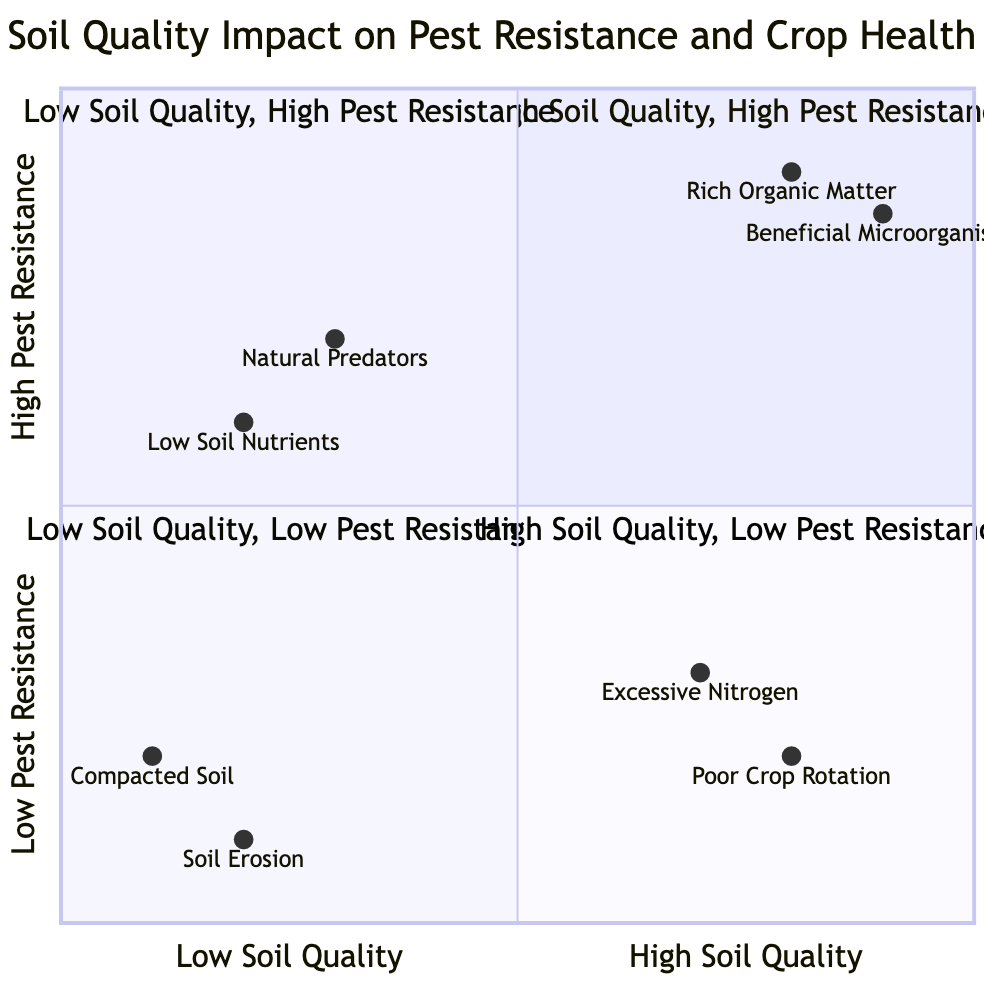What elements are found in the "High Soil Quality, High Pest Resistance" quadrant? The "High Soil Quality, High Pest Resistance" quadrant contains two elements: "Rich Organic Matter" and "Beneficial Microorganisms."
Answer: Rich Organic Matter, Beneficial Microorganisms What does "Compacted Soil" indicate about pest resistance? "Compacted Soil" is located in the "Low Soil Quality, Low Pest Resistance" quadrant, indicating it contributes to low pest resistance due to restricted root growth and water infiltration.
Answer: Low pest resistance How many elements are in the "Low Soil Quality, High Pest Resistance" quadrant? The "Low Soil Quality, High Pest Resistance" quadrant has two elements: "Low Soil Nutrients" and "Natural Predators."
Answer: 2 In which quadrant does "Excessive Nitrogen" belong? "Excessive Nitrogen" is located in the "High Soil Quality, Low Pest Resistance" quadrant, indicating that while the soil quality is high, it may lead to increased susceptibility to pests.
Answer: High Soil Quality, Low Pest Resistance Which element is associated with "High Soil Quality, High Pest Resistance" with the highest Y-coordinate? "Beneficial Microorganisms" has the highest Y-coordinate (0.85) in the "High Soil Quality, High Pest Resistance" quadrant, indicating its significant role in pest resistance.
Answer: Beneficial Microorganisms What is the Y-coordinate of "Soil Erosion"? "Soil Erosion" has a Y-coordinate of 0.1, signifying its low contribution to pest resistance in the "Low Soil Quality, Low Pest Resistance" quadrant.
Answer: 0.1 Which quadrant shows a trade-off between soil quality and pest resistance? The "High Soil Quality, Low Pest Resistance" quadrant indicates that even with high soil quality, pest resistance can be compromised due to practices like over-fertilization.
Answer: High Soil Quality, Low Pest Resistance What describes the relationship between "Poor Crop Rotation" and pest resistance? "Poor Crop Rotation" is located in the "High Soil Quality, Low Pest Resistance" quadrant, indicating that high soil quality does not guarantee pest resistance if crop diversity is lacking.
Answer: Compromised pest resistance What is the primary implication of "Natural Predators" in the "Low Soil Quality, High Pest Resistance" quadrant? "Natural Predators" suggests that even with low soil quality, the presence of predators can help maintain pest levels, indicating a complex balance in pest resistance.
Answer: Maintains pest levels 